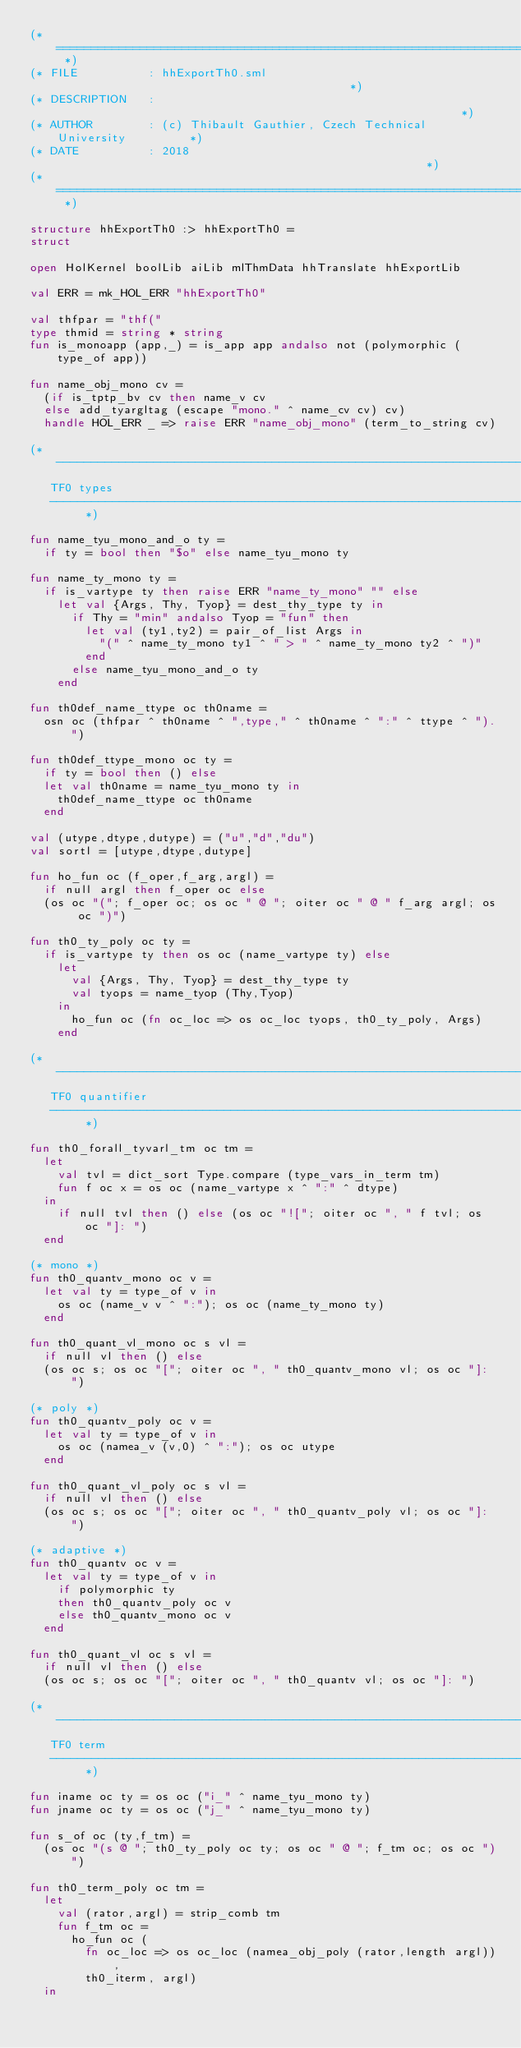Convert code to text. <code><loc_0><loc_0><loc_500><loc_500><_SML_>(* ========================================================================= *)
(* FILE          : hhExportTh0.sml                                           *)
(* DESCRIPTION   :                                                           *)
(* AUTHOR        : (c) Thibault Gauthier, Czech Technical University         *)
(* DATE          : 2018                                                      *)
(* ========================================================================= *)

structure hhExportTh0 :> hhExportTh0 =
struct

open HolKernel boolLib aiLib mlThmData hhTranslate hhExportLib

val ERR = mk_HOL_ERR "hhExportTh0"

val thfpar = "thf("
type thmid = string * string
fun is_monoapp (app,_) = is_app app andalso not (polymorphic (type_of app))

fun name_obj_mono cv =
  (if is_tptp_bv cv then name_v cv
  else add_tyargltag (escape "mono." ^ name_cv cv) cv)
  handle HOL_ERR _ => raise ERR "name_obj_mono" (term_to_string cv)

(* -------------------------------------------------------------------------
   TF0 types
   ------------------------------------------------------------------------- *)

fun name_tyu_mono_and_o ty =
  if ty = bool then "$o" else name_tyu_mono ty

fun name_ty_mono ty =
  if is_vartype ty then raise ERR "name_ty_mono" "" else
    let val {Args, Thy, Tyop} = dest_thy_type ty in
      if Thy = "min" andalso Tyop = "fun" then
        let val (ty1,ty2) = pair_of_list Args in
          "(" ^ name_ty_mono ty1 ^ " > " ^ name_ty_mono ty2 ^ ")"
        end
      else name_tyu_mono_and_o ty
    end

fun th0def_name_ttype oc th0name =
  osn oc (thfpar ^ th0name ^ ",type," ^ th0name ^ ":" ^ ttype ^ ").")

fun th0def_ttype_mono oc ty =
  if ty = bool then () else
  let val th0name = name_tyu_mono ty in
    th0def_name_ttype oc th0name
  end

val (utype,dtype,dutype) = ("u","d","du")
val sortl = [utype,dtype,dutype]

fun ho_fun oc (f_oper,f_arg,argl) =
  if null argl then f_oper oc else
  (os oc "("; f_oper oc; os oc " @ "; oiter oc " @ " f_arg argl; os oc ")")

fun th0_ty_poly oc ty =
  if is_vartype ty then os oc (name_vartype ty) else
    let
      val {Args, Thy, Tyop} = dest_thy_type ty
      val tyops = name_tyop (Thy,Tyop)
    in
      ho_fun oc (fn oc_loc => os oc_loc tyops, th0_ty_poly, Args)
    end

(* -------------------------------------------------------------------------
   TF0 quantifier
   ------------------------------------------------------------------------- *)

fun th0_forall_tyvarl_tm oc tm =
  let
    val tvl = dict_sort Type.compare (type_vars_in_term tm)
    fun f oc x = os oc (name_vartype x ^ ":" ^ dtype)
  in
    if null tvl then () else (os oc "!["; oiter oc ", " f tvl; os oc "]: ")
  end

(* mono *)
fun th0_quantv_mono oc v =
  let val ty = type_of v in
    os oc (name_v v ^ ":"); os oc (name_ty_mono ty)
  end

fun th0_quant_vl_mono oc s vl =
  if null vl then () else
  (os oc s; os oc "["; oiter oc ", " th0_quantv_mono vl; os oc "]: ")

(* poly *)
fun th0_quantv_poly oc v =
  let val ty = type_of v in
    os oc (namea_v (v,0) ^ ":"); os oc utype
  end

fun th0_quant_vl_poly oc s vl =
  if null vl then () else
  (os oc s; os oc "["; oiter oc ", " th0_quantv_poly vl; os oc "]: ")

(* adaptive *)
fun th0_quantv oc v =
  let val ty = type_of v in
    if polymorphic ty
    then th0_quantv_poly oc v
    else th0_quantv_mono oc v
  end

fun th0_quant_vl oc s vl =
  if null vl then () else
  (os oc s; os oc "["; oiter oc ", " th0_quantv vl; os oc "]: ")

(* -------------------------------------------------------------------------
   TF0 term
   ------------------------------------------------------------------------- *)

fun iname oc ty = os oc ("i_" ^ name_tyu_mono ty)
fun jname oc ty = os oc ("j_" ^ name_tyu_mono ty)

fun s_of oc (ty,f_tm) =
  (os oc "(s @ "; th0_ty_poly oc ty; os oc " @ "; f_tm oc; os oc ")")

fun th0_term_poly oc tm =
  let
    val (rator,argl) = strip_comb tm
    fun f_tm oc =
      ho_fun oc (
        fn oc_loc => os oc_loc (namea_obj_poly (rator,length argl)),
        th0_iterm, argl)
  in</code> 